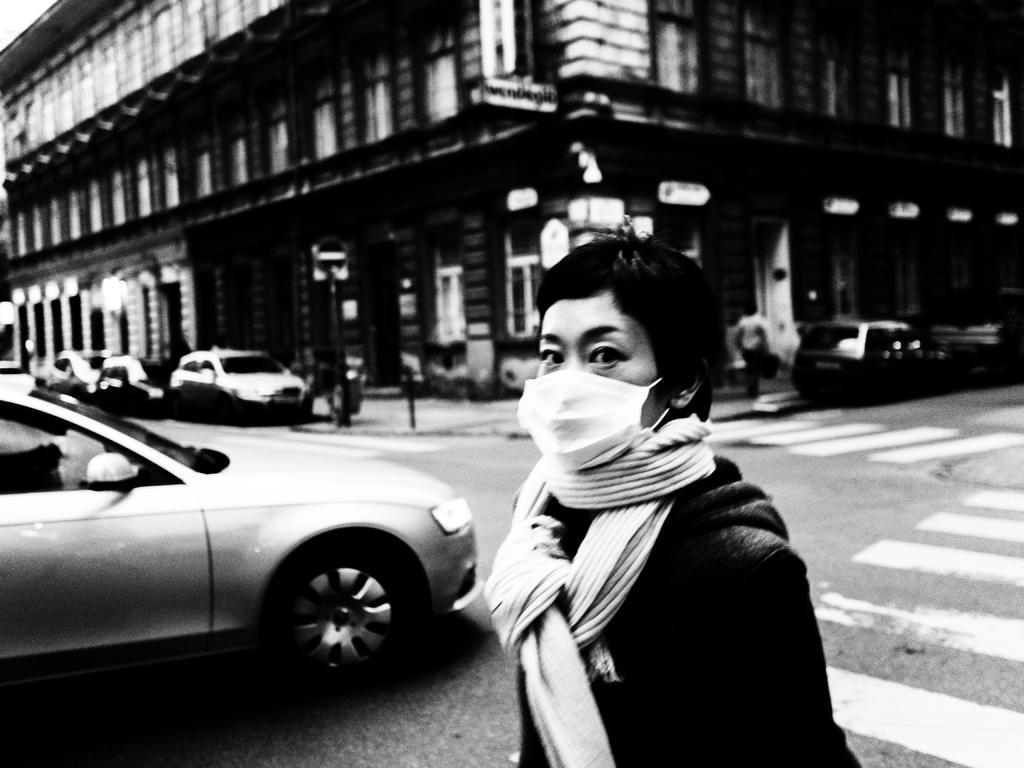Describe this image in one or two sentences. In this picture we can see group of people, few vehicles and a building, in the middle of the image we can see a woman, she wore a mask, and it is a black and white photography. 